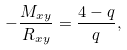Convert formula to latex. <formula><loc_0><loc_0><loc_500><loc_500>- \frac { M _ { x y } } { R _ { x y } } = \frac { 4 - q } { q } ,</formula> 